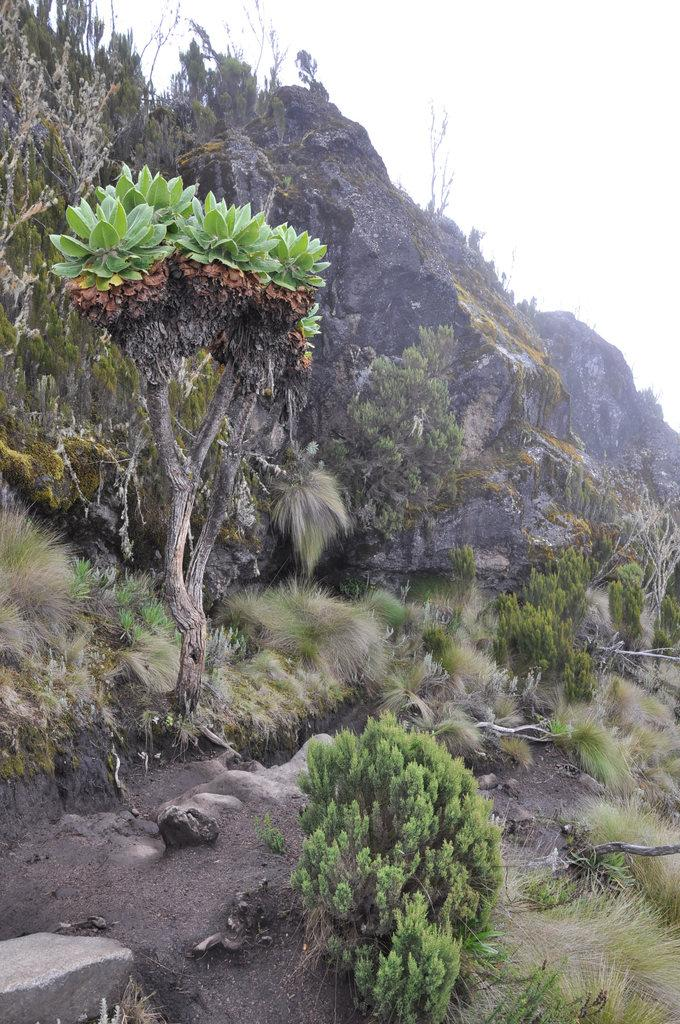What type of vegetation can be seen in the image? There are trees, plants, and grass visible in the image. Where are the trees, plants, and grass located? They are on a hill in the image. What is visible in the background of the image? The sky is visible in the background of the image. What type of thing can be seen making a profit on the edge of the hill in the image? There is no thing or profit-making activity present in the image; it features trees, plants, and grass on a hill. 